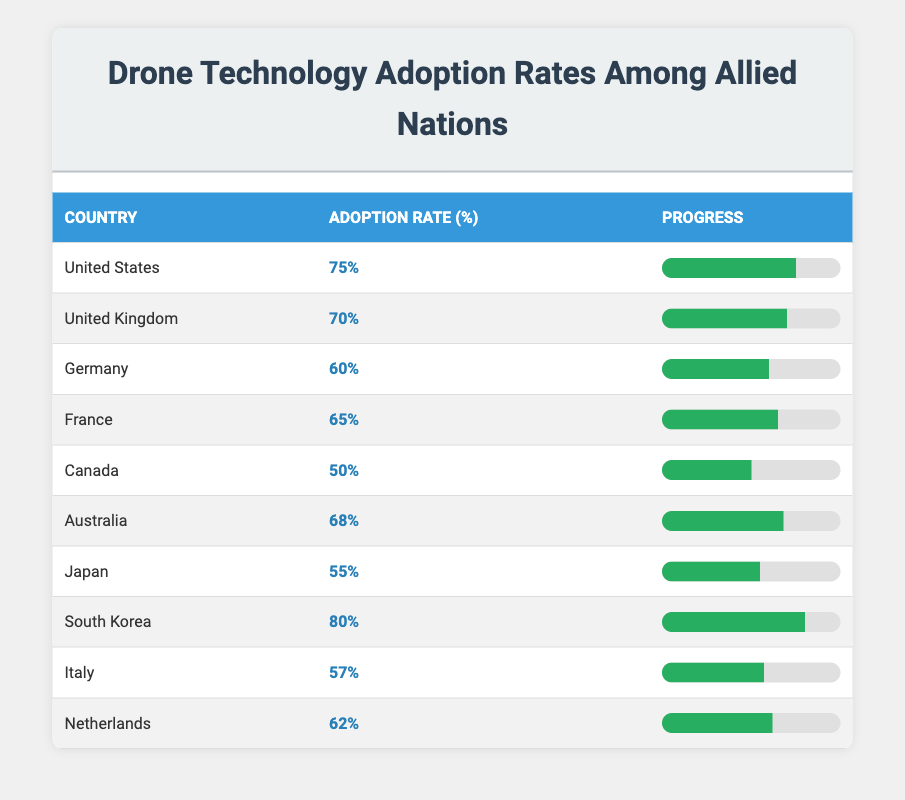What is the highest drone adoption rate among allied nations? The table shows a list of countries along with their respective drone adoption rates. Scanning through the rates, the highest adoption rate is found under South Korea at 80%.
Answer: 80% Which country has the lowest drone adoption rate? Looking at the adoption rates in the table, Canada has the lowest rate at 50%.
Answer: Canada What is the average drone adoption rate among the listed nations? To find the average, we sum all the adoption rates: (75 + 70 + 60 + 65 + 50 + 68 + 55 + 80 + 57 + 62) =  747. Then, we divide by the number of countries, which is 10. Therefore, 747 / 10 = 74.7.
Answer: 74.7 Is it true that Germany has a higher drone adoption rate than Japan? By comparing the adoption rates from the table, Germany has a rate of 60% while Japan has a rate of 55%. Since 60% is greater than 55%, the statement is true.
Answer: Yes Which nations have adoption rates that are above the average? The average rate calculated earlier is 74.7%. The countries with higher rates are the United States (75%), South Korea (80%), and Australia (68%). Summing these, we find the countries above the average are the United States and South Korea.
Answer: United States, South Korea 